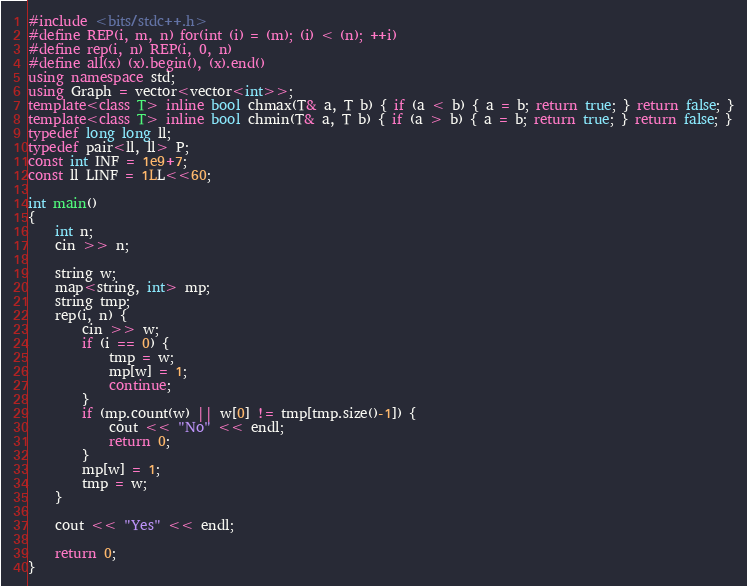<code> <loc_0><loc_0><loc_500><loc_500><_C++_>#include <bits/stdc++.h>
#define REP(i, m, n) for(int (i) = (m); (i) < (n); ++i)
#define rep(i, n) REP(i, 0, n)
#define all(x) (x).begin(), (x).end()
using namespace std;
using Graph = vector<vector<int>>;
template<class T> inline bool chmax(T& a, T b) { if (a < b) { a = b; return true; } return false; }
template<class T> inline bool chmin(T& a, T b) { if (a > b) { a = b; return true; } return false; }
typedef long long ll;
typedef pair<ll, ll> P;
const int INF = 1e9+7;
const ll LINF = 1LL<<60;

int main()
{
    int n;
    cin >> n;

    string w;
    map<string, int> mp;
    string tmp;
    rep(i, n) {
        cin >> w;
        if (i == 0) {
            tmp = w;
            mp[w] = 1;
            continue;
        }
        if (mp.count(w) || w[0] != tmp[tmp.size()-1]) {
            cout << "No" << endl;
            return 0;
        }
        mp[w] = 1;
        tmp = w;
    }

    cout << "Yes" << endl;

    return 0;
}</code> 